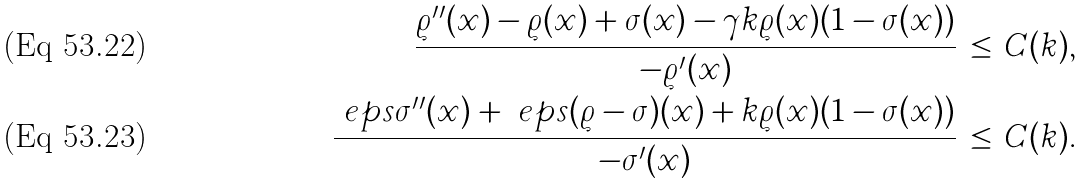Convert formula to latex. <formula><loc_0><loc_0><loc_500><loc_500>\frac { \varrho ^ { \prime \prime } ( x ) - \varrho ( x ) + \sigma ( x ) - \gamma k \varrho ( x ) ( 1 - \sigma ( x ) ) } { - \varrho ^ { \prime } ( x ) } \, & \leq \, C ( k ) , \\ \frac { \ e p s \sigma ^ { \prime \prime } ( x ) + \ e p s ( \varrho - \sigma ) ( x ) + k \varrho ( x ) ( 1 - \sigma ( x ) ) } { - \sigma ^ { \prime } ( x ) } \, & \leq \, C ( k ) .</formula> 